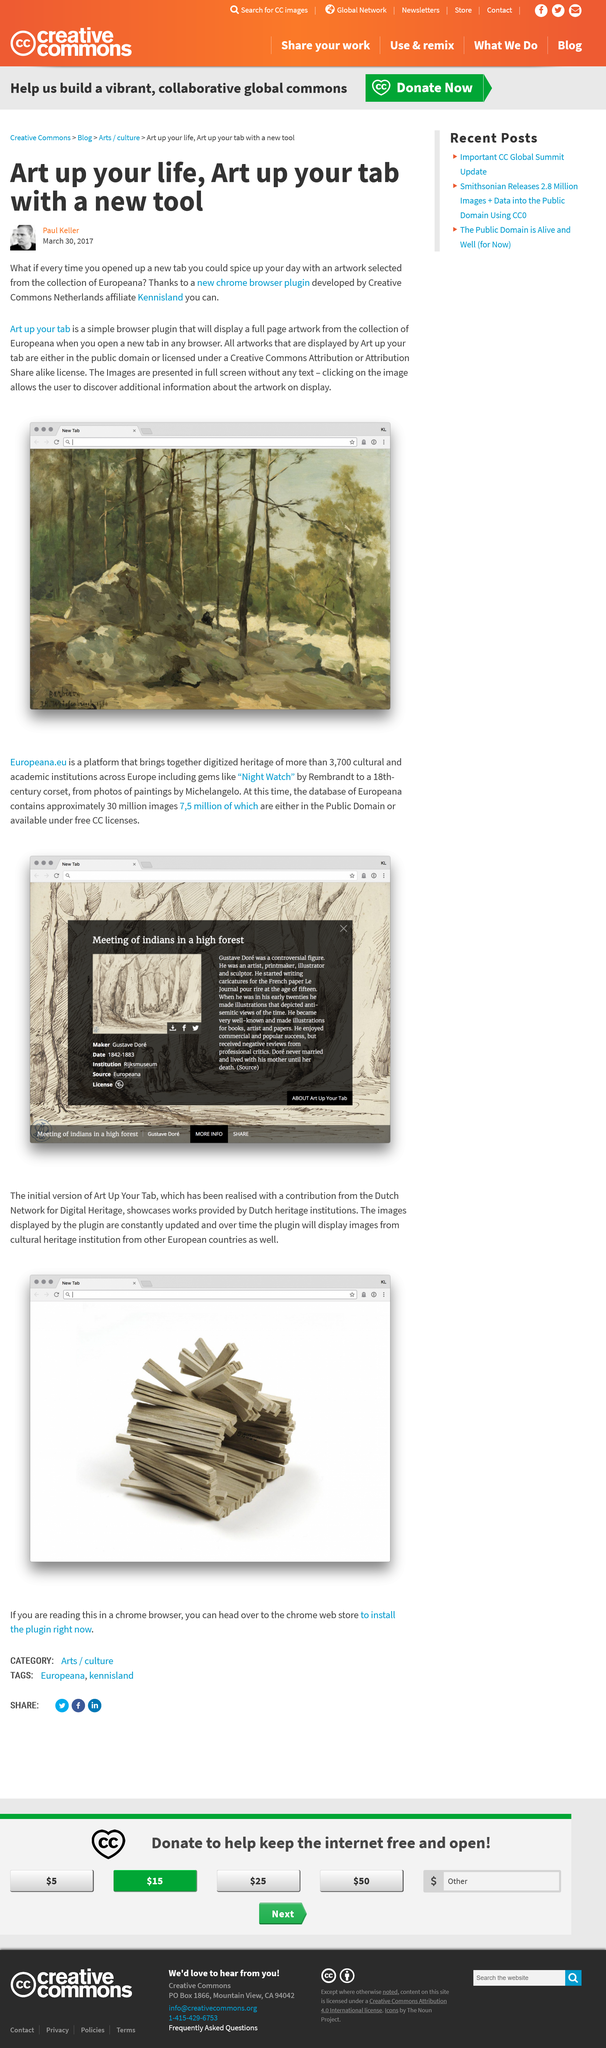List a handful of essential elements in this visual. Art up your tab is a browser plugin that displays full-page artwork from the collection of Europeana when a new tab is opened in any web browser. All images displayed on my browser through art up your tab are either in the public domain or licensed under a Creative Commons attribution or attribution-share alike license. The artwork on my life is created by Paul Keller, the author of the article. 